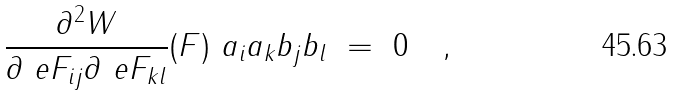<formula> <loc_0><loc_0><loc_500><loc_500>\frac { \partial ^ { 2 } W } { \partial \ e F _ { i j } \partial \ e F _ { k l } } ( F ) \ a _ { i } a _ { k } b _ { j } b _ { l } \ = \ 0 \quad ,</formula> 